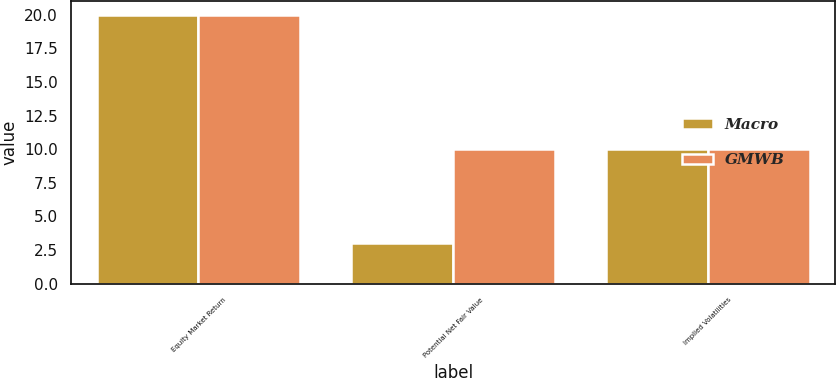<chart> <loc_0><loc_0><loc_500><loc_500><stacked_bar_chart><ecel><fcel>Equity Market Return<fcel>Potential Net Fair Value<fcel>Implied Volatilities<nl><fcel>Macro<fcel>20<fcel>3<fcel>10<nl><fcel>GMWB<fcel>20<fcel>10<fcel>10<nl></chart> 